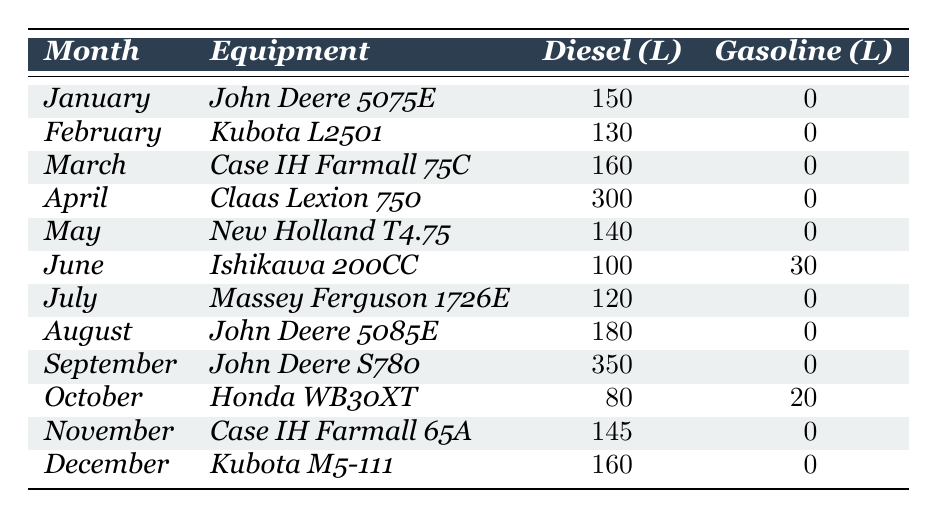What is the total diesel consumption for the month of April? The table indicates that in April, the Claas Lexion 750 had a diesel consumption of 300 liters. Thus, the total for that month is simply that value.
Answer: 300 liters Which month had the highest diesel consumption? By reviewing the diesel consumption values for each month, September shows the highest figure at 350 liters for the John Deere S780.
Answer: September How much gasoline was consumed in June? In June, the Ishikawa 200CC irrigation pump used 30 liters of gasoline, as specified in the table.
Answer: 30 liters What is the average diesel consumption over the entire year? To find the average, I add all diesel consumption values: (150 + 130 + 160 + 300 + 140 + 100 + 120 + 180 + 350 + 80 + 145 + 160) = 1,335 liters. There are 12 months, so the average is 1,335 / 12 = 111.25 liters.
Answer: 111.25 liters Which equipment had the lowest diesel consumption and in which month? The Honda WB30XT irrigation pump had the lowest diesel consumption in October with 80 liters. This is found by comparing all diesel values across the table.
Answer: Honda WB30XT in October Is there any month where gasoline consumption was greater than diesel consumption? By examining the gasoline and diesel figures, I see that in June, there was gasoline consumption (30 liters) alongside diesel consumption (100 liters), but diesel consumption is greater in that month. Therefore, there is no month where gasoline is greater than diesel.
Answer: No What is the total diesel consumption from January to March? For January to March, the diesel consumption values are 150 liters (January) + 130 liters (February) + 160 liters (March). Adding them up gives 150 + 130 + 160 = 440 liters.
Answer: 440 liters How many months had zero gasoline consumption? By inspecting the table, only June and October had gasoline consumption, while the other months (10) had zero gasoline consumption. Thus, the total is 10 months without gasoline use.
Answer: 10 months What is the difference in diesel consumption between September and January? The diesel consumption in September is 350 liters and in January is 150 liters, so the difference is 350 - 150 = 200 liters.
Answer: 200 liters In which month was the equipment not a tractor but still used diesel? In April and October, equipment other than tractors was used: Claas Lexion 750 in April and Honda WB30XT in October, both consuming diesel.
Answer: April and October 